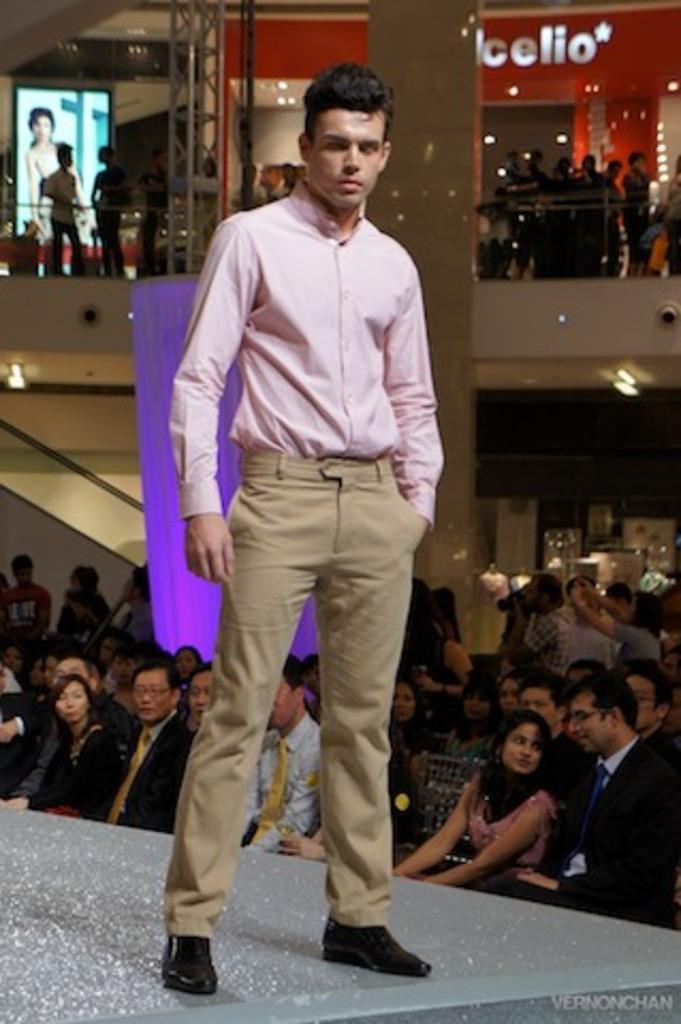In one or two sentences, can you explain what this image depicts? In the image in the center we can see one person standing. In the background there is a wall,screen,banner,pillar,curtain and lights. And group of people were sitting. 